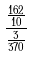<formula> <loc_0><loc_0><loc_500><loc_500>\frac { \frac { 1 6 2 } { 1 0 } } { \frac { 3 } { 3 7 0 } }</formula> 